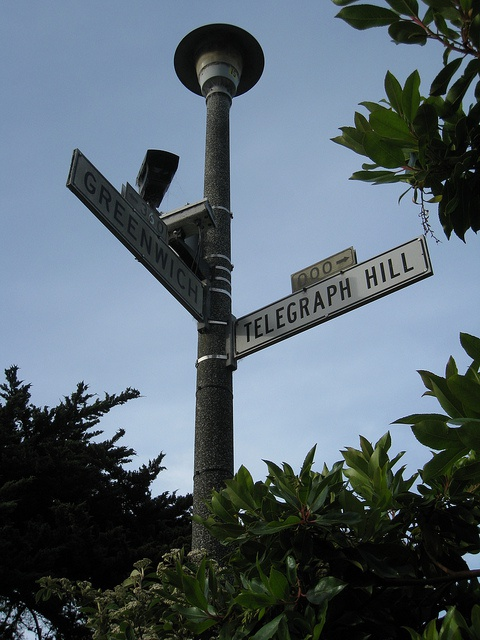Describe the objects in this image and their specific colors. I can see various objects in this image with different colors. 